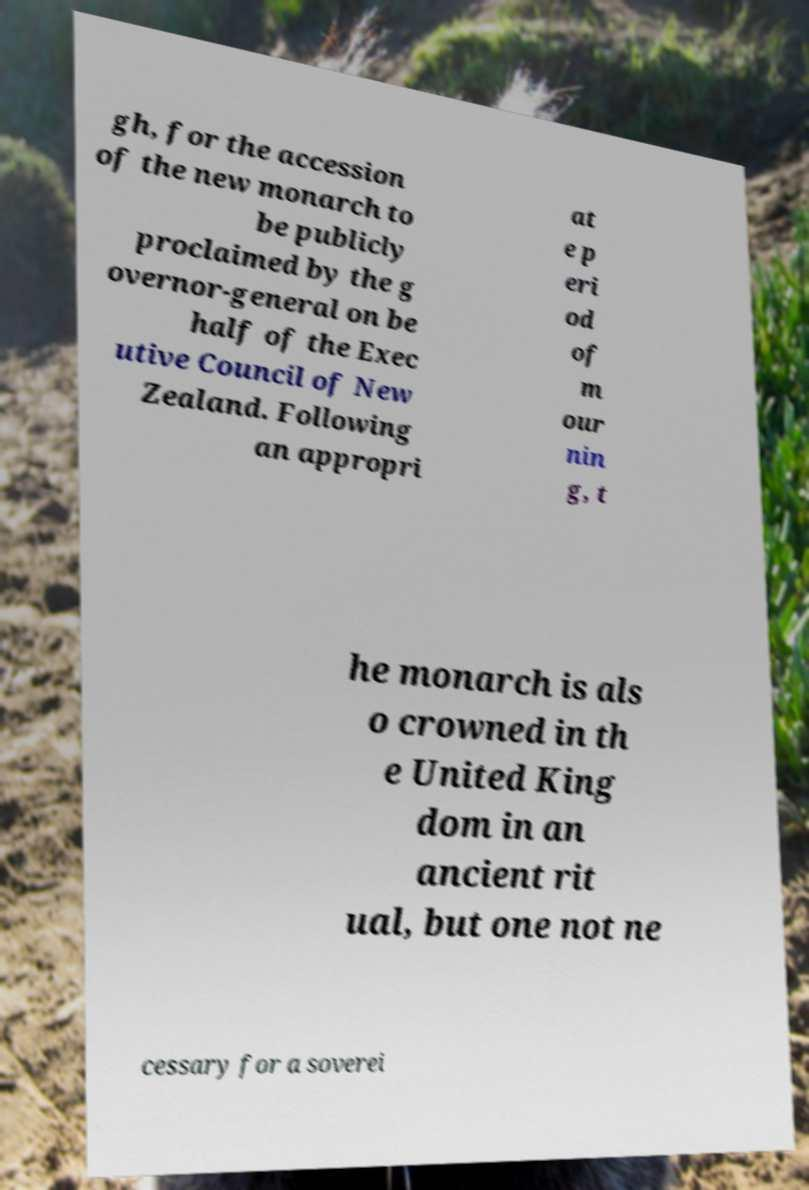What messages or text are displayed in this image? I need them in a readable, typed format. gh, for the accession of the new monarch to be publicly proclaimed by the g overnor-general on be half of the Exec utive Council of New Zealand. Following an appropri at e p eri od of m our nin g, t he monarch is als o crowned in th e United King dom in an ancient rit ual, but one not ne cessary for a soverei 